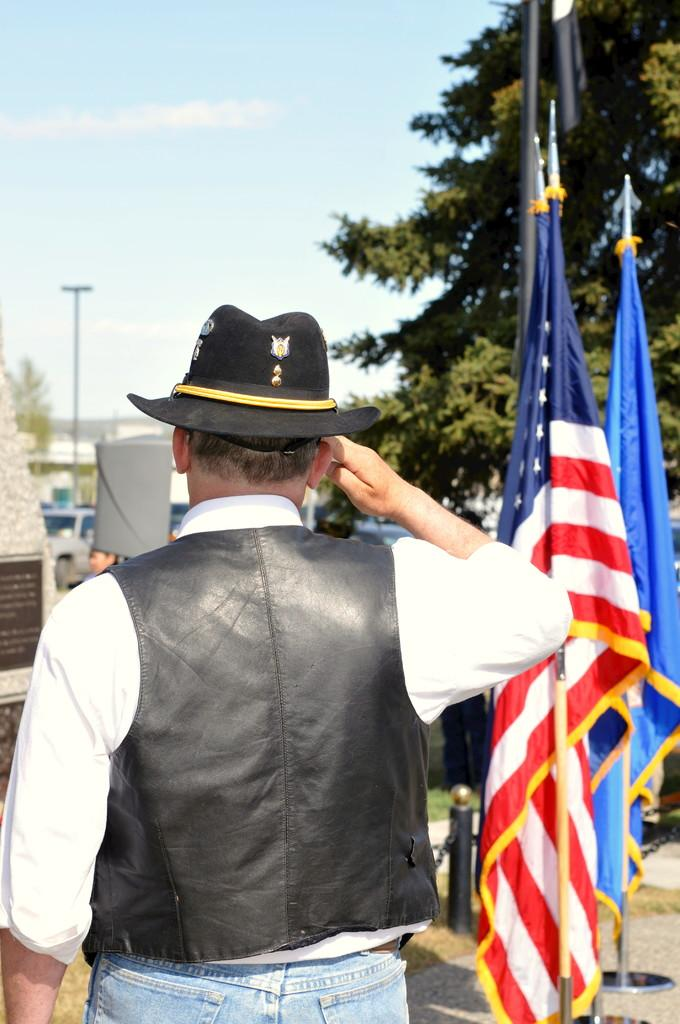What is located in the foreground of the image? In the foreground of the image, there are flags, a cornerstone, grass, and a person. Can you describe the middle section of the image? In the middle of the image, there are trees, cars, a pole, and other objects. What is visible at the top of the image? Sky is visible at the top of the image. What type of flower can be seen growing in the middle of the image? There are no flowers visible in the image; the middle section contains trees, cars, a pole, and other objects. 